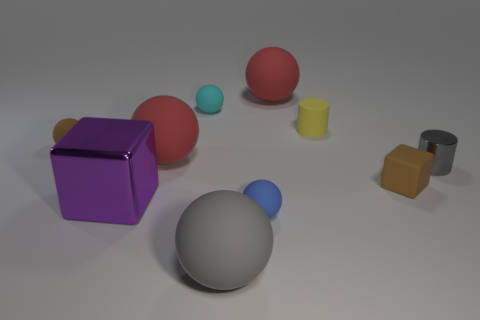There is a brown thing in front of the brown object that is behind the small gray metallic thing; what shape is it?
Keep it short and to the point. Cube. What number of cylinders are red matte objects or tiny gray metallic things?
Provide a succinct answer. 1. What material is the big sphere that is behind the large gray matte thing and in front of the tiny cyan sphere?
Your answer should be compact. Rubber. There is a tiny yellow cylinder; how many blue rubber spheres are on the left side of it?
Offer a terse response. 1. Do the tiny cylinder left of the tiny brown matte block and the small brown object behind the tiny shiny cylinder have the same material?
Your answer should be compact. Yes. What number of objects are big rubber objects that are in front of the small rubber block or tiny cyan metallic objects?
Your response must be concise. 1. Is the number of things on the right side of the tiny brown cube less than the number of cyan matte spheres in front of the blue matte ball?
Offer a terse response. No. What number of other things are the same size as the yellow rubber cylinder?
Make the answer very short. 5. Is the material of the gray ball the same as the thing to the left of the purple metal cube?
Your answer should be compact. Yes. How many objects are spheres behind the tiny block or matte spheres behind the cyan ball?
Your response must be concise. 4. 